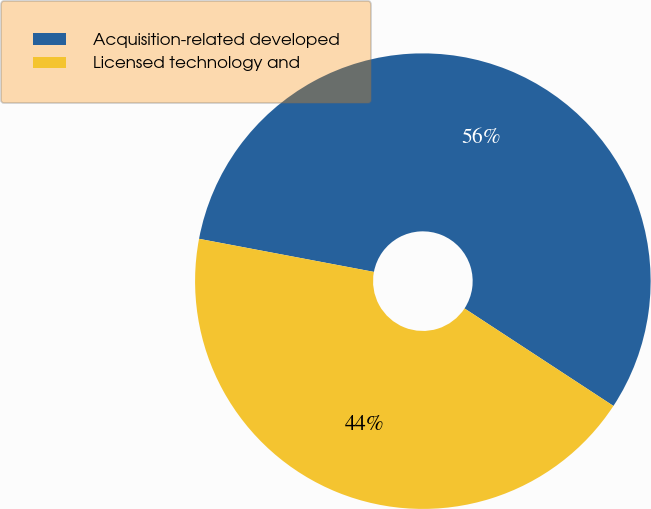<chart> <loc_0><loc_0><loc_500><loc_500><pie_chart><fcel>Acquisition-related developed<fcel>Licensed technology and<nl><fcel>56.25%<fcel>43.75%<nl></chart> 